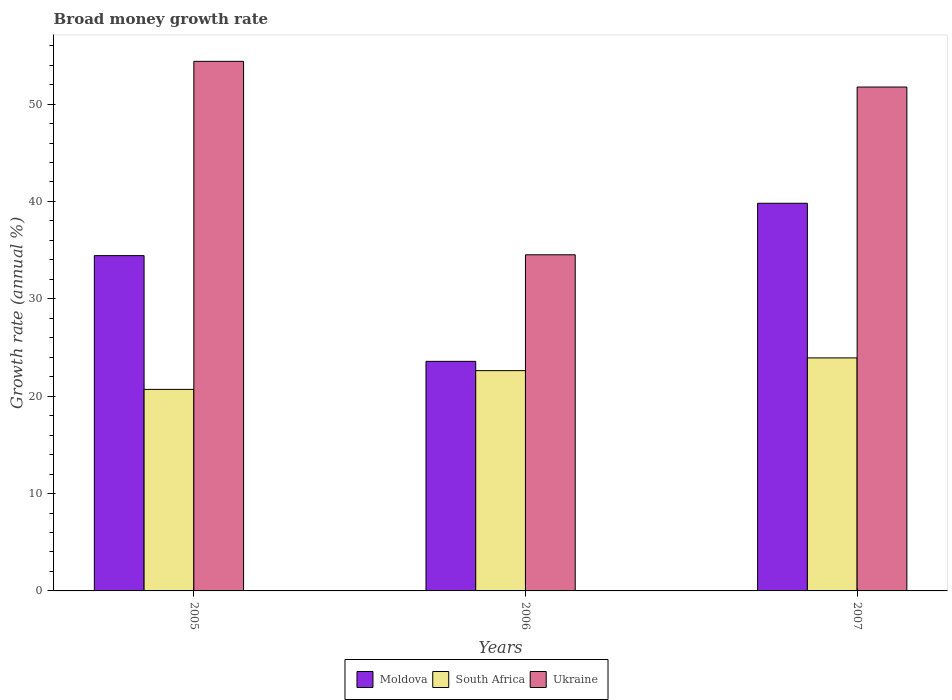How many bars are there on the 3rd tick from the left?
Offer a very short reply. 3. In how many cases, is the number of bars for a given year not equal to the number of legend labels?
Your answer should be compact. 0. What is the growth rate in Ukraine in 2005?
Offer a terse response. 54.39. Across all years, what is the maximum growth rate in South Africa?
Keep it short and to the point. 23.93. Across all years, what is the minimum growth rate in Ukraine?
Your answer should be compact. 34.52. In which year was the growth rate in Moldova maximum?
Give a very brief answer. 2007. In which year was the growth rate in Ukraine minimum?
Ensure brevity in your answer.  2006. What is the total growth rate in South Africa in the graph?
Ensure brevity in your answer.  67.25. What is the difference between the growth rate in South Africa in 2005 and that in 2006?
Offer a terse response. -1.93. What is the difference between the growth rate in Moldova in 2007 and the growth rate in Ukraine in 2006?
Your response must be concise. 5.29. What is the average growth rate in Moldova per year?
Keep it short and to the point. 32.61. In the year 2007, what is the difference between the growth rate in Ukraine and growth rate in South Africa?
Provide a succinct answer. 27.82. What is the ratio of the growth rate in Moldova in 2005 to that in 2006?
Your answer should be very brief. 1.46. What is the difference between the highest and the second highest growth rate in Ukraine?
Provide a succinct answer. 2.64. What is the difference between the highest and the lowest growth rate in Moldova?
Your answer should be very brief. 16.23. In how many years, is the growth rate in Moldova greater than the average growth rate in Moldova taken over all years?
Your response must be concise. 2. What does the 3rd bar from the left in 2005 represents?
Offer a very short reply. Ukraine. What does the 1st bar from the right in 2007 represents?
Provide a short and direct response. Ukraine. Are all the bars in the graph horizontal?
Give a very brief answer. No. How many years are there in the graph?
Your answer should be very brief. 3. Are the values on the major ticks of Y-axis written in scientific E-notation?
Make the answer very short. No. How many legend labels are there?
Make the answer very short. 3. How are the legend labels stacked?
Your answer should be compact. Horizontal. What is the title of the graph?
Your answer should be very brief. Broad money growth rate. What is the label or title of the X-axis?
Provide a short and direct response. Years. What is the label or title of the Y-axis?
Your response must be concise. Growth rate (annual %). What is the Growth rate (annual %) in Moldova in 2005?
Make the answer very short. 34.43. What is the Growth rate (annual %) of South Africa in 2005?
Keep it short and to the point. 20.7. What is the Growth rate (annual %) in Ukraine in 2005?
Your response must be concise. 54.39. What is the Growth rate (annual %) in Moldova in 2006?
Your answer should be compact. 23.58. What is the Growth rate (annual %) in South Africa in 2006?
Provide a succinct answer. 22.62. What is the Growth rate (annual %) of Ukraine in 2006?
Provide a short and direct response. 34.52. What is the Growth rate (annual %) in Moldova in 2007?
Your answer should be compact. 39.81. What is the Growth rate (annual %) in South Africa in 2007?
Your answer should be very brief. 23.93. What is the Growth rate (annual %) of Ukraine in 2007?
Give a very brief answer. 51.75. Across all years, what is the maximum Growth rate (annual %) in Moldova?
Keep it short and to the point. 39.81. Across all years, what is the maximum Growth rate (annual %) in South Africa?
Give a very brief answer. 23.93. Across all years, what is the maximum Growth rate (annual %) in Ukraine?
Ensure brevity in your answer.  54.39. Across all years, what is the minimum Growth rate (annual %) of Moldova?
Make the answer very short. 23.58. Across all years, what is the minimum Growth rate (annual %) of South Africa?
Keep it short and to the point. 20.7. Across all years, what is the minimum Growth rate (annual %) in Ukraine?
Offer a terse response. 34.52. What is the total Growth rate (annual %) of Moldova in the graph?
Offer a terse response. 97.82. What is the total Growth rate (annual %) of South Africa in the graph?
Make the answer very short. 67.25. What is the total Growth rate (annual %) of Ukraine in the graph?
Offer a terse response. 140.65. What is the difference between the Growth rate (annual %) of Moldova in 2005 and that in 2006?
Make the answer very short. 10.86. What is the difference between the Growth rate (annual %) in South Africa in 2005 and that in 2006?
Offer a terse response. -1.93. What is the difference between the Growth rate (annual %) in Ukraine in 2005 and that in 2006?
Your response must be concise. 19.87. What is the difference between the Growth rate (annual %) in Moldova in 2005 and that in 2007?
Keep it short and to the point. -5.38. What is the difference between the Growth rate (annual %) in South Africa in 2005 and that in 2007?
Keep it short and to the point. -3.23. What is the difference between the Growth rate (annual %) of Ukraine in 2005 and that in 2007?
Your response must be concise. 2.64. What is the difference between the Growth rate (annual %) in Moldova in 2006 and that in 2007?
Provide a succinct answer. -16.23. What is the difference between the Growth rate (annual %) of South Africa in 2006 and that in 2007?
Your answer should be very brief. -1.31. What is the difference between the Growth rate (annual %) in Ukraine in 2006 and that in 2007?
Keep it short and to the point. -17.23. What is the difference between the Growth rate (annual %) of Moldova in 2005 and the Growth rate (annual %) of South Africa in 2006?
Offer a very short reply. 11.81. What is the difference between the Growth rate (annual %) of Moldova in 2005 and the Growth rate (annual %) of Ukraine in 2006?
Your answer should be very brief. -0.09. What is the difference between the Growth rate (annual %) in South Africa in 2005 and the Growth rate (annual %) in Ukraine in 2006?
Ensure brevity in your answer.  -13.82. What is the difference between the Growth rate (annual %) in Moldova in 2005 and the Growth rate (annual %) in South Africa in 2007?
Offer a terse response. 10.5. What is the difference between the Growth rate (annual %) of Moldova in 2005 and the Growth rate (annual %) of Ukraine in 2007?
Make the answer very short. -17.31. What is the difference between the Growth rate (annual %) in South Africa in 2005 and the Growth rate (annual %) in Ukraine in 2007?
Make the answer very short. -31.05. What is the difference between the Growth rate (annual %) of Moldova in 2006 and the Growth rate (annual %) of South Africa in 2007?
Ensure brevity in your answer.  -0.36. What is the difference between the Growth rate (annual %) of Moldova in 2006 and the Growth rate (annual %) of Ukraine in 2007?
Ensure brevity in your answer.  -28.17. What is the difference between the Growth rate (annual %) of South Africa in 2006 and the Growth rate (annual %) of Ukraine in 2007?
Provide a short and direct response. -29.12. What is the average Growth rate (annual %) of Moldova per year?
Provide a short and direct response. 32.61. What is the average Growth rate (annual %) of South Africa per year?
Keep it short and to the point. 22.42. What is the average Growth rate (annual %) in Ukraine per year?
Ensure brevity in your answer.  46.88. In the year 2005, what is the difference between the Growth rate (annual %) in Moldova and Growth rate (annual %) in South Africa?
Your response must be concise. 13.74. In the year 2005, what is the difference between the Growth rate (annual %) of Moldova and Growth rate (annual %) of Ukraine?
Your answer should be very brief. -19.95. In the year 2005, what is the difference between the Growth rate (annual %) of South Africa and Growth rate (annual %) of Ukraine?
Keep it short and to the point. -33.69. In the year 2006, what is the difference between the Growth rate (annual %) of Moldova and Growth rate (annual %) of South Africa?
Offer a very short reply. 0.95. In the year 2006, what is the difference between the Growth rate (annual %) of Moldova and Growth rate (annual %) of Ukraine?
Give a very brief answer. -10.94. In the year 2006, what is the difference between the Growth rate (annual %) of South Africa and Growth rate (annual %) of Ukraine?
Your answer should be compact. -11.9. In the year 2007, what is the difference between the Growth rate (annual %) of Moldova and Growth rate (annual %) of South Africa?
Offer a very short reply. 15.88. In the year 2007, what is the difference between the Growth rate (annual %) of Moldova and Growth rate (annual %) of Ukraine?
Keep it short and to the point. -11.94. In the year 2007, what is the difference between the Growth rate (annual %) of South Africa and Growth rate (annual %) of Ukraine?
Offer a very short reply. -27.82. What is the ratio of the Growth rate (annual %) in Moldova in 2005 to that in 2006?
Give a very brief answer. 1.46. What is the ratio of the Growth rate (annual %) in South Africa in 2005 to that in 2006?
Make the answer very short. 0.91. What is the ratio of the Growth rate (annual %) of Ukraine in 2005 to that in 2006?
Provide a short and direct response. 1.58. What is the ratio of the Growth rate (annual %) in Moldova in 2005 to that in 2007?
Provide a short and direct response. 0.86. What is the ratio of the Growth rate (annual %) in South Africa in 2005 to that in 2007?
Keep it short and to the point. 0.86. What is the ratio of the Growth rate (annual %) of Ukraine in 2005 to that in 2007?
Your answer should be very brief. 1.05. What is the ratio of the Growth rate (annual %) of Moldova in 2006 to that in 2007?
Keep it short and to the point. 0.59. What is the ratio of the Growth rate (annual %) in South Africa in 2006 to that in 2007?
Offer a very short reply. 0.95. What is the ratio of the Growth rate (annual %) in Ukraine in 2006 to that in 2007?
Offer a terse response. 0.67. What is the difference between the highest and the second highest Growth rate (annual %) in Moldova?
Provide a short and direct response. 5.38. What is the difference between the highest and the second highest Growth rate (annual %) in South Africa?
Provide a short and direct response. 1.31. What is the difference between the highest and the second highest Growth rate (annual %) of Ukraine?
Your answer should be compact. 2.64. What is the difference between the highest and the lowest Growth rate (annual %) of Moldova?
Keep it short and to the point. 16.23. What is the difference between the highest and the lowest Growth rate (annual %) of South Africa?
Your response must be concise. 3.23. What is the difference between the highest and the lowest Growth rate (annual %) of Ukraine?
Make the answer very short. 19.87. 